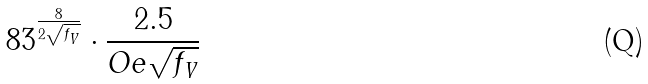Convert formula to latex. <formula><loc_0><loc_0><loc_500><loc_500>8 3 ^ { \frac { 8 } { 2 \sqrt { f _ { V } } } } \cdot \frac { 2 . 5 } { O e \sqrt { f _ { V } } }</formula> 